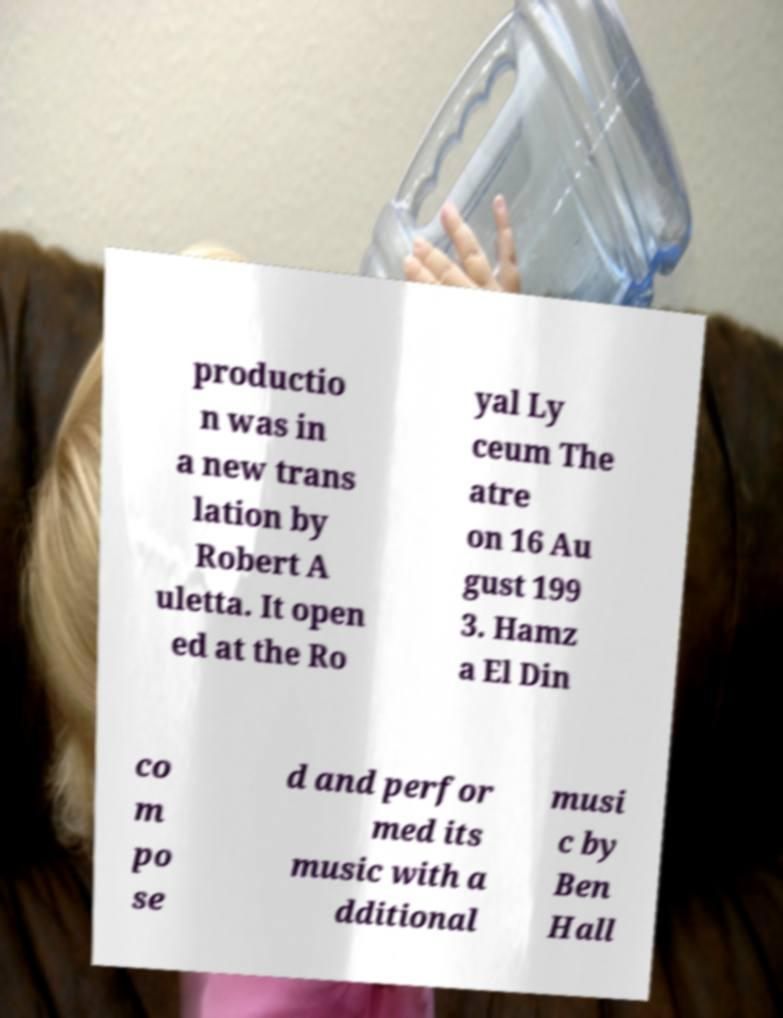Please identify and transcribe the text found in this image. productio n was in a new trans lation by Robert A uletta. It open ed at the Ro yal Ly ceum The atre on 16 Au gust 199 3. Hamz a El Din co m po se d and perfor med its music with a dditional musi c by Ben Hall 